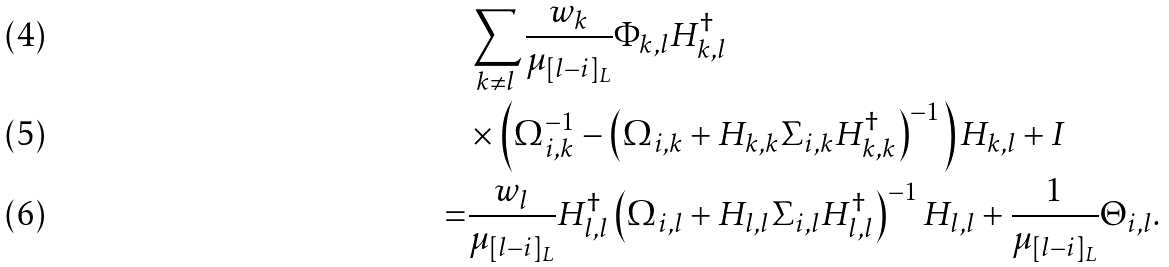<formula> <loc_0><loc_0><loc_500><loc_500>& \sum _ { k \neq l } \frac { w _ { k } } { \mu _ { [ l - i ] _ { L } } } \Phi _ { k , l } H _ { k , l } ^ { \dagger } \\ & \times \left ( \Omega _ { i , k } ^ { - 1 } - \left ( \Omega _ { i , k } + H _ { k , k } \Sigma _ { i , k } H _ { k , k } ^ { \dagger } \right ) ^ { - 1 } \right ) H _ { k , l } + I \\ = & \frac { w _ { l } } { \mu _ { [ l - i ] _ { L } } } H _ { l , l } ^ { \dagger } \left ( \Omega _ { i , l } + H _ { l , l } \Sigma _ { i , l } H _ { l , l } ^ { \dagger } \right ) ^ { - 1 } H _ { l , l } + \frac { 1 } { \mu _ { [ l - i ] _ { L } } } \Theta _ { i , l } .</formula> 